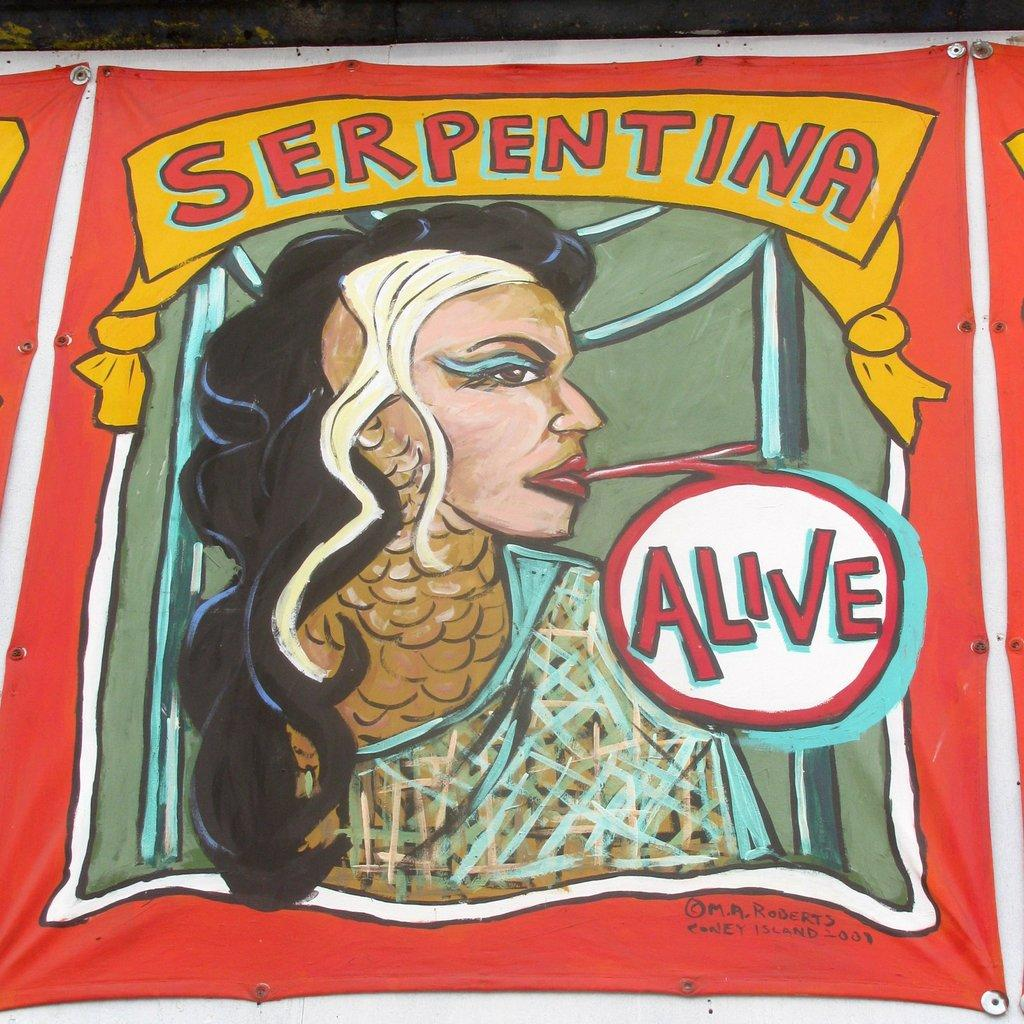What is present on both sides of the image? There are banners on both the right and left sides of the image. What is the purpose of the banners? The banners contain text and a human depicted on them, which suggests they might be used for advertising or conveying information. Can you describe the banner in the image? The banner in the image contains text and a human depicted on it. How many cows are grazing in the bushes near the school in the image? There are no cows or bushes near a school present in the image; it only features banners with text and a human depicted on them. 